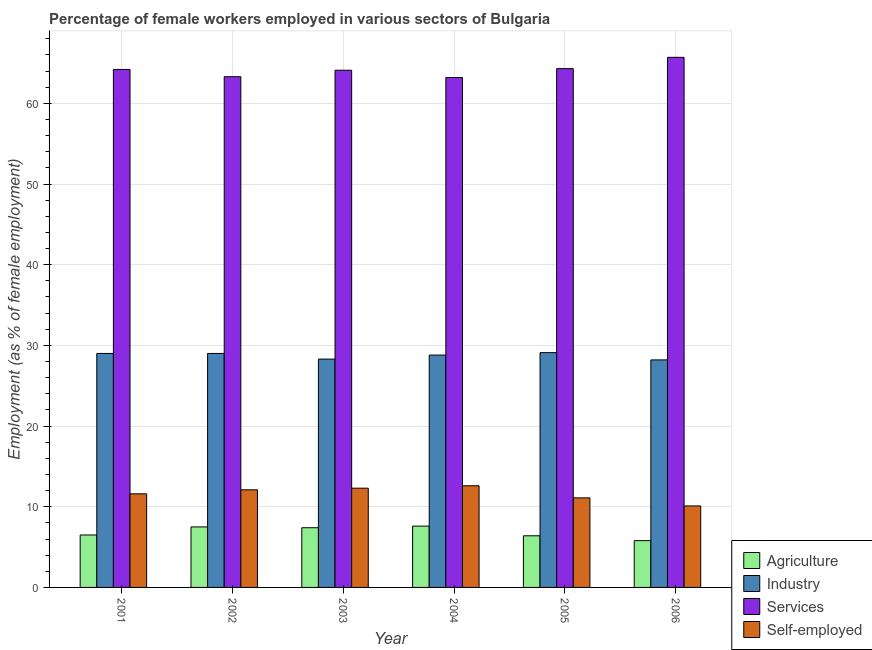How many different coloured bars are there?
Keep it short and to the point. 4. How many groups of bars are there?
Provide a succinct answer. 6. Are the number of bars per tick equal to the number of legend labels?
Your answer should be very brief. Yes. Are the number of bars on each tick of the X-axis equal?
Offer a very short reply. Yes. How many bars are there on the 5th tick from the left?
Provide a succinct answer. 4. In how many cases, is the number of bars for a given year not equal to the number of legend labels?
Your response must be concise. 0. What is the percentage of female workers in services in 2003?
Make the answer very short. 64.1. Across all years, what is the maximum percentage of female workers in agriculture?
Ensure brevity in your answer.  7.6. Across all years, what is the minimum percentage of female workers in services?
Make the answer very short. 63.2. In which year was the percentage of female workers in services maximum?
Your response must be concise. 2006. In which year was the percentage of female workers in services minimum?
Your answer should be very brief. 2004. What is the total percentage of female workers in agriculture in the graph?
Provide a short and direct response. 41.2. What is the difference between the percentage of female workers in agriculture in 2001 and that in 2003?
Provide a succinct answer. -0.9. What is the difference between the percentage of female workers in industry in 2005 and the percentage of female workers in agriculture in 2006?
Ensure brevity in your answer.  0.9. What is the average percentage of female workers in services per year?
Make the answer very short. 64.13. In how many years, is the percentage of female workers in industry greater than 54 %?
Provide a succinct answer. 0. What is the ratio of the percentage of female workers in services in 2002 to that in 2006?
Ensure brevity in your answer.  0.96. What is the difference between the highest and the second highest percentage of female workers in agriculture?
Provide a succinct answer. 0.1. What is the difference between the highest and the lowest percentage of female workers in industry?
Your response must be concise. 0.9. Is the sum of the percentage of female workers in agriculture in 2001 and 2003 greater than the maximum percentage of female workers in industry across all years?
Ensure brevity in your answer.  Yes. Is it the case that in every year, the sum of the percentage of female workers in agriculture and percentage of self employed female workers is greater than the sum of percentage of female workers in services and percentage of female workers in industry?
Provide a succinct answer. No. What does the 3rd bar from the left in 2005 represents?
Give a very brief answer. Services. What does the 3rd bar from the right in 2001 represents?
Provide a short and direct response. Industry. How many bars are there?
Your response must be concise. 24. Are the values on the major ticks of Y-axis written in scientific E-notation?
Provide a succinct answer. No. Does the graph contain any zero values?
Offer a very short reply. No. Does the graph contain grids?
Ensure brevity in your answer.  Yes. Where does the legend appear in the graph?
Provide a short and direct response. Bottom right. How many legend labels are there?
Offer a terse response. 4. What is the title of the graph?
Ensure brevity in your answer.  Percentage of female workers employed in various sectors of Bulgaria. What is the label or title of the Y-axis?
Make the answer very short. Employment (as % of female employment). What is the Employment (as % of female employment) of Agriculture in 2001?
Offer a very short reply. 6.5. What is the Employment (as % of female employment) in Industry in 2001?
Offer a very short reply. 29. What is the Employment (as % of female employment) of Services in 2001?
Give a very brief answer. 64.2. What is the Employment (as % of female employment) in Self-employed in 2001?
Your response must be concise. 11.6. What is the Employment (as % of female employment) of Services in 2002?
Ensure brevity in your answer.  63.3. What is the Employment (as % of female employment) in Self-employed in 2002?
Give a very brief answer. 12.1. What is the Employment (as % of female employment) of Agriculture in 2003?
Give a very brief answer. 7.4. What is the Employment (as % of female employment) of Industry in 2003?
Make the answer very short. 28.3. What is the Employment (as % of female employment) of Services in 2003?
Make the answer very short. 64.1. What is the Employment (as % of female employment) in Self-employed in 2003?
Your answer should be very brief. 12.3. What is the Employment (as % of female employment) of Agriculture in 2004?
Offer a very short reply. 7.6. What is the Employment (as % of female employment) in Industry in 2004?
Your answer should be very brief. 28.8. What is the Employment (as % of female employment) in Services in 2004?
Provide a succinct answer. 63.2. What is the Employment (as % of female employment) of Self-employed in 2004?
Give a very brief answer. 12.6. What is the Employment (as % of female employment) in Agriculture in 2005?
Provide a succinct answer. 6.4. What is the Employment (as % of female employment) in Industry in 2005?
Offer a very short reply. 29.1. What is the Employment (as % of female employment) in Services in 2005?
Offer a very short reply. 64.3. What is the Employment (as % of female employment) in Self-employed in 2005?
Offer a very short reply. 11.1. What is the Employment (as % of female employment) of Agriculture in 2006?
Ensure brevity in your answer.  5.8. What is the Employment (as % of female employment) in Industry in 2006?
Ensure brevity in your answer.  28.2. What is the Employment (as % of female employment) of Services in 2006?
Ensure brevity in your answer.  65.7. What is the Employment (as % of female employment) of Self-employed in 2006?
Offer a very short reply. 10.1. Across all years, what is the maximum Employment (as % of female employment) of Agriculture?
Make the answer very short. 7.6. Across all years, what is the maximum Employment (as % of female employment) in Industry?
Provide a short and direct response. 29.1. Across all years, what is the maximum Employment (as % of female employment) of Services?
Your answer should be very brief. 65.7. Across all years, what is the maximum Employment (as % of female employment) in Self-employed?
Provide a short and direct response. 12.6. Across all years, what is the minimum Employment (as % of female employment) in Agriculture?
Your response must be concise. 5.8. Across all years, what is the minimum Employment (as % of female employment) in Industry?
Your answer should be compact. 28.2. Across all years, what is the minimum Employment (as % of female employment) of Services?
Offer a terse response. 63.2. Across all years, what is the minimum Employment (as % of female employment) in Self-employed?
Your answer should be compact. 10.1. What is the total Employment (as % of female employment) in Agriculture in the graph?
Keep it short and to the point. 41.2. What is the total Employment (as % of female employment) of Industry in the graph?
Your answer should be very brief. 172.4. What is the total Employment (as % of female employment) of Services in the graph?
Offer a very short reply. 384.8. What is the total Employment (as % of female employment) of Self-employed in the graph?
Offer a terse response. 69.8. What is the difference between the Employment (as % of female employment) of Industry in 2001 and that in 2002?
Offer a very short reply. 0. What is the difference between the Employment (as % of female employment) in Agriculture in 2001 and that in 2003?
Offer a very short reply. -0.9. What is the difference between the Employment (as % of female employment) in Industry in 2001 and that in 2003?
Keep it short and to the point. 0.7. What is the difference between the Employment (as % of female employment) of Agriculture in 2001 and that in 2004?
Your answer should be very brief. -1.1. What is the difference between the Employment (as % of female employment) in Services in 2001 and that in 2005?
Give a very brief answer. -0.1. What is the difference between the Employment (as % of female employment) in Self-employed in 2001 and that in 2005?
Ensure brevity in your answer.  0.5. What is the difference between the Employment (as % of female employment) of Industry in 2001 and that in 2006?
Offer a terse response. 0.8. What is the difference between the Employment (as % of female employment) in Services in 2001 and that in 2006?
Provide a succinct answer. -1.5. What is the difference between the Employment (as % of female employment) in Self-employed in 2001 and that in 2006?
Ensure brevity in your answer.  1.5. What is the difference between the Employment (as % of female employment) of Services in 2002 and that in 2003?
Offer a terse response. -0.8. What is the difference between the Employment (as % of female employment) of Self-employed in 2002 and that in 2003?
Provide a short and direct response. -0.2. What is the difference between the Employment (as % of female employment) in Agriculture in 2002 and that in 2004?
Make the answer very short. -0.1. What is the difference between the Employment (as % of female employment) in Self-employed in 2002 and that in 2004?
Give a very brief answer. -0.5. What is the difference between the Employment (as % of female employment) of Agriculture in 2002 and that in 2005?
Your response must be concise. 1.1. What is the difference between the Employment (as % of female employment) of Services in 2002 and that in 2005?
Offer a very short reply. -1. What is the difference between the Employment (as % of female employment) in Self-employed in 2002 and that in 2005?
Your answer should be very brief. 1. What is the difference between the Employment (as % of female employment) of Industry in 2002 and that in 2006?
Your response must be concise. 0.8. What is the difference between the Employment (as % of female employment) in Services in 2002 and that in 2006?
Your answer should be very brief. -2.4. What is the difference between the Employment (as % of female employment) in Self-employed in 2002 and that in 2006?
Provide a short and direct response. 2. What is the difference between the Employment (as % of female employment) of Agriculture in 2003 and that in 2004?
Ensure brevity in your answer.  -0.2. What is the difference between the Employment (as % of female employment) of Industry in 2003 and that in 2004?
Ensure brevity in your answer.  -0.5. What is the difference between the Employment (as % of female employment) of Services in 2003 and that in 2005?
Keep it short and to the point. -0.2. What is the difference between the Employment (as % of female employment) of Self-employed in 2003 and that in 2005?
Keep it short and to the point. 1.2. What is the difference between the Employment (as % of female employment) in Services in 2003 and that in 2006?
Give a very brief answer. -1.6. What is the difference between the Employment (as % of female employment) in Self-employed in 2003 and that in 2006?
Keep it short and to the point. 2.2. What is the difference between the Employment (as % of female employment) in Self-employed in 2004 and that in 2005?
Make the answer very short. 1.5. What is the difference between the Employment (as % of female employment) in Services in 2005 and that in 2006?
Your response must be concise. -1.4. What is the difference between the Employment (as % of female employment) of Self-employed in 2005 and that in 2006?
Your answer should be compact. 1. What is the difference between the Employment (as % of female employment) in Agriculture in 2001 and the Employment (as % of female employment) in Industry in 2002?
Provide a short and direct response. -22.5. What is the difference between the Employment (as % of female employment) of Agriculture in 2001 and the Employment (as % of female employment) of Services in 2002?
Offer a terse response. -56.8. What is the difference between the Employment (as % of female employment) of Industry in 2001 and the Employment (as % of female employment) of Services in 2002?
Give a very brief answer. -34.3. What is the difference between the Employment (as % of female employment) of Industry in 2001 and the Employment (as % of female employment) of Self-employed in 2002?
Your response must be concise. 16.9. What is the difference between the Employment (as % of female employment) in Services in 2001 and the Employment (as % of female employment) in Self-employed in 2002?
Provide a short and direct response. 52.1. What is the difference between the Employment (as % of female employment) in Agriculture in 2001 and the Employment (as % of female employment) in Industry in 2003?
Ensure brevity in your answer.  -21.8. What is the difference between the Employment (as % of female employment) in Agriculture in 2001 and the Employment (as % of female employment) in Services in 2003?
Offer a terse response. -57.6. What is the difference between the Employment (as % of female employment) of Industry in 2001 and the Employment (as % of female employment) of Services in 2003?
Your response must be concise. -35.1. What is the difference between the Employment (as % of female employment) in Industry in 2001 and the Employment (as % of female employment) in Self-employed in 2003?
Give a very brief answer. 16.7. What is the difference between the Employment (as % of female employment) of Services in 2001 and the Employment (as % of female employment) of Self-employed in 2003?
Give a very brief answer. 51.9. What is the difference between the Employment (as % of female employment) in Agriculture in 2001 and the Employment (as % of female employment) in Industry in 2004?
Give a very brief answer. -22.3. What is the difference between the Employment (as % of female employment) in Agriculture in 2001 and the Employment (as % of female employment) in Services in 2004?
Offer a very short reply. -56.7. What is the difference between the Employment (as % of female employment) of Industry in 2001 and the Employment (as % of female employment) of Services in 2004?
Provide a short and direct response. -34.2. What is the difference between the Employment (as % of female employment) of Services in 2001 and the Employment (as % of female employment) of Self-employed in 2004?
Make the answer very short. 51.6. What is the difference between the Employment (as % of female employment) of Agriculture in 2001 and the Employment (as % of female employment) of Industry in 2005?
Keep it short and to the point. -22.6. What is the difference between the Employment (as % of female employment) in Agriculture in 2001 and the Employment (as % of female employment) in Services in 2005?
Your answer should be compact. -57.8. What is the difference between the Employment (as % of female employment) in Agriculture in 2001 and the Employment (as % of female employment) in Self-employed in 2005?
Provide a succinct answer. -4.6. What is the difference between the Employment (as % of female employment) in Industry in 2001 and the Employment (as % of female employment) in Services in 2005?
Make the answer very short. -35.3. What is the difference between the Employment (as % of female employment) of Industry in 2001 and the Employment (as % of female employment) of Self-employed in 2005?
Provide a short and direct response. 17.9. What is the difference between the Employment (as % of female employment) in Services in 2001 and the Employment (as % of female employment) in Self-employed in 2005?
Your answer should be compact. 53.1. What is the difference between the Employment (as % of female employment) in Agriculture in 2001 and the Employment (as % of female employment) in Industry in 2006?
Your answer should be very brief. -21.7. What is the difference between the Employment (as % of female employment) in Agriculture in 2001 and the Employment (as % of female employment) in Services in 2006?
Ensure brevity in your answer.  -59.2. What is the difference between the Employment (as % of female employment) of Industry in 2001 and the Employment (as % of female employment) of Services in 2006?
Your response must be concise. -36.7. What is the difference between the Employment (as % of female employment) of Services in 2001 and the Employment (as % of female employment) of Self-employed in 2006?
Provide a short and direct response. 54.1. What is the difference between the Employment (as % of female employment) of Agriculture in 2002 and the Employment (as % of female employment) of Industry in 2003?
Make the answer very short. -20.8. What is the difference between the Employment (as % of female employment) of Agriculture in 2002 and the Employment (as % of female employment) of Services in 2003?
Keep it short and to the point. -56.6. What is the difference between the Employment (as % of female employment) in Industry in 2002 and the Employment (as % of female employment) in Services in 2003?
Offer a terse response. -35.1. What is the difference between the Employment (as % of female employment) of Industry in 2002 and the Employment (as % of female employment) of Self-employed in 2003?
Offer a very short reply. 16.7. What is the difference between the Employment (as % of female employment) of Agriculture in 2002 and the Employment (as % of female employment) of Industry in 2004?
Keep it short and to the point. -21.3. What is the difference between the Employment (as % of female employment) in Agriculture in 2002 and the Employment (as % of female employment) in Services in 2004?
Make the answer very short. -55.7. What is the difference between the Employment (as % of female employment) in Industry in 2002 and the Employment (as % of female employment) in Services in 2004?
Offer a very short reply. -34.2. What is the difference between the Employment (as % of female employment) in Services in 2002 and the Employment (as % of female employment) in Self-employed in 2004?
Provide a succinct answer. 50.7. What is the difference between the Employment (as % of female employment) in Agriculture in 2002 and the Employment (as % of female employment) in Industry in 2005?
Offer a terse response. -21.6. What is the difference between the Employment (as % of female employment) of Agriculture in 2002 and the Employment (as % of female employment) of Services in 2005?
Make the answer very short. -56.8. What is the difference between the Employment (as % of female employment) in Agriculture in 2002 and the Employment (as % of female employment) in Self-employed in 2005?
Your answer should be very brief. -3.6. What is the difference between the Employment (as % of female employment) in Industry in 2002 and the Employment (as % of female employment) in Services in 2005?
Offer a very short reply. -35.3. What is the difference between the Employment (as % of female employment) in Industry in 2002 and the Employment (as % of female employment) in Self-employed in 2005?
Offer a terse response. 17.9. What is the difference between the Employment (as % of female employment) in Services in 2002 and the Employment (as % of female employment) in Self-employed in 2005?
Offer a terse response. 52.2. What is the difference between the Employment (as % of female employment) in Agriculture in 2002 and the Employment (as % of female employment) in Industry in 2006?
Ensure brevity in your answer.  -20.7. What is the difference between the Employment (as % of female employment) of Agriculture in 2002 and the Employment (as % of female employment) of Services in 2006?
Offer a terse response. -58.2. What is the difference between the Employment (as % of female employment) in Industry in 2002 and the Employment (as % of female employment) in Services in 2006?
Your answer should be compact. -36.7. What is the difference between the Employment (as % of female employment) in Industry in 2002 and the Employment (as % of female employment) in Self-employed in 2006?
Your answer should be very brief. 18.9. What is the difference between the Employment (as % of female employment) of Services in 2002 and the Employment (as % of female employment) of Self-employed in 2006?
Ensure brevity in your answer.  53.2. What is the difference between the Employment (as % of female employment) of Agriculture in 2003 and the Employment (as % of female employment) of Industry in 2004?
Give a very brief answer. -21.4. What is the difference between the Employment (as % of female employment) in Agriculture in 2003 and the Employment (as % of female employment) in Services in 2004?
Keep it short and to the point. -55.8. What is the difference between the Employment (as % of female employment) in Industry in 2003 and the Employment (as % of female employment) in Services in 2004?
Ensure brevity in your answer.  -34.9. What is the difference between the Employment (as % of female employment) in Industry in 2003 and the Employment (as % of female employment) in Self-employed in 2004?
Your answer should be compact. 15.7. What is the difference between the Employment (as % of female employment) of Services in 2003 and the Employment (as % of female employment) of Self-employed in 2004?
Give a very brief answer. 51.5. What is the difference between the Employment (as % of female employment) in Agriculture in 2003 and the Employment (as % of female employment) in Industry in 2005?
Give a very brief answer. -21.7. What is the difference between the Employment (as % of female employment) of Agriculture in 2003 and the Employment (as % of female employment) of Services in 2005?
Keep it short and to the point. -56.9. What is the difference between the Employment (as % of female employment) of Agriculture in 2003 and the Employment (as % of female employment) of Self-employed in 2005?
Give a very brief answer. -3.7. What is the difference between the Employment (as % of female employment) of Industry in 2003 and the Employment (as % of female employment) of Services in 2005?
Give a very brief answer. -36. What is the difference between the Employment (as % of female employment) of Industry in 2003 and the Employment (as % of female employment) of Self-employed in 2005?
Provide a succinct answer. 17.2. What is the difference between the Employment (as % of female employment) in Services in 2003 and the Employment (as % of female employment) in Self-employed in 2005?
Make the answer very short. 53. What is the difference between the Employment (as % of female employment) in Agriculture in 2003 and the Employment (as % of female employment) in Industry in 2006?
Your response must be concise. -20.8. What is the difference between the Employment (as % of female employment) of Agriculture in 2003 and the Employment (as % of female employment) of Services in 2006?
Offer a terse response. -58.3. What is the difference between the Employment (as % of female employment) in Agriculture in 2003 and the Employment (as % of female employment) in Self-employed in 2006?
Your response must be concise. -2.7. What is the difference between the Employment (as % of female employment) of Industry in 2003 and the Employment (as % of female employment) of Services in 2006?
Give a very brief answer. -37.4. What is the difference between the Employment (as % of female employment) in Industry in 2003 and the Employment (as % of female employment) in Self-employed in 2006?
Ensure brevity in your answer.  18.2. What is the difference between the Employment (as % of female employment) of Services in 2003 and the Employment (as % of female employment) of Self-employed in 2006?
Ensure brevity in your answer.  54. What is the difference between the Employment (as % of female employment) of Agriculture in 2004 and the Employment (as % of female employment) of Industry in 2005?
Ensure brevity in your answer.  -21.5. What is the difference between the Employment (as % of female employment) in Agriculture in 2004 and the Employment (as % of female employment) in Services in 2005?
Offer a terse response. -56.7. What is the difference between the Employment (as % of female employment) of Agriculture in 2004 and the Employment (as % of female employment) of Self-employed in 2005?
Keep it short and to the point. -3.5. What is the difference between the Employment (as % of female employment) of Industry in 2004 and the Employment (as % of female employment) of Services in 2005?
Offer a very short reply. -35.5. What is the difference between the Employment (as % of female employment) in Industry in 2004 and the Employment (as % of female employment) in Self-employed in 2005?
Provide a succinct answer. 17.7. What is the difference between the Employment (as % of female employment) in Services in 2004 and the Employment (as % of female employment) in Self-employed in 2005?
Your response must be concise. 52.1. What is the difference between the Employment (as % of female employment) of Agriculture in 2004 and the Employment (as % of female employment) of Industry in 2006?
Keep it short and to the point. -20.6. What is the difference between the Employment (as % of female employment) of Agriculture in 2004 and the Employment (as % of female employment) of Services in 2006?
Provide a short and direct response. -58.1. What is the difference between the Employment (as % of female employment) of Industry in 2004 and the Employment (as % of female employment) of Services in 2006?
Your answer should be very brief. -36.9. What is the difference between the Employment (as % of female employment) of Industry in 2004 and the Employment (as % of female employment) of Self-employed in 2006?
Offer a very short reply. 18.7. What is the difference between the Employment (as % of female employment) in Services in 2004 and the Employment (as % of female employment) in Self-employed in 2006?
Your answer should be very brief. 53.1. What is the difference between the Employment (as % of female employment) of Agriculture in 2005 and the Employment (as % of female employment) of Industry in 2006?
Provide a succinct answer. -21.8. What is the difference between the Employment (as % of female employment) in Agriculture in 2005 and the Employment (as % of female employment) in Services in 2006?
Provide a succinct answer. -59.3. What is the difference between the Employment (as % of female employment) of Agriculture in 2005 and the Employment (as % of female employment) of Self-employed in 2006?
Your answer should be compact. -3.7. What is the difference between the Employment (as % of female employment) of Industry in 2005 and the Employment (as % of female employment) of Services in 2006?
Make the answer very short. -36.6. What is the difference between the Employment (as % of female employment) in Services in 2005 and the Employment (as % of female employment) in Self-employed in 2006?
Your response must be concise. 54.2. What is the average Employment (as % of female employment) in Agriculture per year?
Keep it short and to the point. 6.87. What is the average Employment (as % of female employment) in Industry per year?
Ensure brevity in your answer.  28.73. What is the average Employment (as % of female employment) of Services per year?
Offer a very short reply. 64.13. What is the average Employment (as % of female employment) in Self-employed per year?
Provide a short and direct response. 11.63. In the year 2001, what is the difference between the Employment (as % of female employment) of Agriculture and Employment (as % of female employment) of Industry?
Provide a short and direct response. -22.5. In the year 2001, what is the difference between the Employment (as % of female employment) in Agriculture and Employment (as % of female employment) in Services?
Provide a succinct answer. -57.7. In the year 2001, what is the difference between the Employment (as % of female employment) in Agriculture and Employment (as % of female employment) in Self-employed?
Make the answer very short. -5.1. In the year 2001, what is the difference between the Employment (as % of female employment) in Industry and Employment (as % of female employment) in Services?
Your answer should be very brief. -35.2. In the year 2001, what is the difference between the Employment (as % of female employment) of Services and Employment (as % of female employment) of Self-employed?
Provide a succinct answer. 52.6. In the year 2002, what is the difference between the Employment (as % of female employment) of Agriculture and Employment (as % of female employment) of Industry?
Offer a very short reply. -21.5. In the year 2002, what is the difference between the Employment (as % of female employment) of Agriculture and Employment (as % of female employment) of Services?
Your response must be concise. -55.8. In the year 2002, what is the difference between the Employment (as % of female employment) in Industry and Employment (as % of female employment) in Services?
Give a very brief answer. -34.3. In the year 2002, what is the difference between the Employment (as % of female employment) of Services and Employment (as % of female employment) of Self-employed?
Ensure brevity in your answer.  51.2. In the year 2003, what is the difference between the Employment (as % of female employment) of Agriculture and Employment (as % of female employment) of Industry?
Offer a terse response. -20.9. In the year 2003, what is the difference between the Employment (as % of female employment) in Agriculture and Employment (as % of female employment) in Services?
Provide a succinct answer. -56.7. In the year 2003, what is the difference between the Employment (as % of female employment) in Industry and Employment (as % of female employment) in Services?
Offer a terse response. -35.8. In the year 2003, what is the difference between the Employment (as % of female employment) of Services and Employment (as % of female employment) of Self-employed?
Give a very brief answer. 51.8. In the year 2004, what is the difference between the Employment (as % of female employment) of Agriculture and Employment (as % of female employment) of Industry?
Offer a very short reply. -21.2. In the year 2004, what is the difference between the Employment (as % of female employment) of Agriculture and Employment (as % of female employment) of Services?
Your answer should be compact. -55.6. In the year 2004, what is the difference between the Employment (as % of female employment) of Industry and Employment (as % of female employment) of Services?
Offer a terse response. -34.4. In the year 2004, what is the difference between the Employment (as % of female employment) of Services and Employment (as % of female employment) of Self-employed?
Give a very brief answer. 50.6. In the year 2005, what is the difference between the Employment (as % of female employment) of Agriculture and Employment (as % of female employment) of Industry?
Provide a succinct answer. -22.7. In the year 2005, what is the difference between the Employment (as % of female employment) of Agriculture and Employment (as % of female employment) of Services?
Ensure brevity in your answer.  -57.9. In the year 2005, what is the difference between the Employment (as % of female employment) of Industry and Employment (as % of female employment) of Services?
Your answer should be very brief. -35.2. In the year 2005, what is the difference between the Employment (as % of female employment) in Industry and Employment (as % of female employment) in Self-employed?
Provide a succinct answer. 18. In the year 2005, what is the difference between the Employment (as % of female employment) of Services and Employment (as % of female employment) of Self-employed?
Offer a terse response. 53.2. In the year 2006, what is the difference between the Employment (as % of female employment) of Agriculture and Employment (as % of female employment) of Industry?
Give a very brief answer. -22.4. In the year 2006, what is the difference between the Employment (as % of female employment) in Agriculture and Employment (as % of female employment) in Services?
Make the answer very short. -59.9. In the year 2006, what is the difference between the Employment (as % of female employment) in Agriculture and Employment (as % of female employment) in Self-employed?
Your answer should be very brief. -4.3. In the year 2006, what is the difference between the Employment (as % of female employment) of Industry and Employment (as % of female employment) of Services?
Give a very brief answer. -37.5. In the year 2006, what is the difference between the Employment (as % of female employment) in Industry and Employment (as % of female employment) in Self-employed?
Provide a succinct answer. 18.1. In the year 2006, what is the difference between the Employment (as % of female employment) in Services and Employment (as % of female employment) in Self-employed?
Offer a very short reply. 55.6. What is the ratio of the Employment (as % of female employment) of Agriculture in 2001 to that in 2002?
Provide a succinct answer. 0.87. What is the ratio of the Employment (as % of female employment) of Services in 2001 to that in 2002?
Ensure brevity in your answer.  1.01. What is the ratio of the Employment (as % of female employment) of Self-employed in 2001 to that in 2002?
Give a very brief answer. 0.96. What is the ratio of the Employment (as % of female employment) in Agriculture in 2001 to that in 2003?
Offer a terse response. 0.88. What is the ratio of the Employment (as % of female employment) in Industry in 2001 to that in 2003?
Your answer should be compact. 1.02. What is the ratio of the Employment (as % of female employment) of Self-employed in 2001 to that in 2003?
Offer a terse response. 0.94. What is the ratio of the Employment (as % of female employment) of Agriculture in 2001 to that in 2004?
Your response must be concise. 0.86. What is the ratio of the Employment (as % of female employment) of Services in 2001 to that in 2004?
Offer a terse response. 1.02. What is the ratio of the Employment (as % of female employment) of Self-employed in 2001 to that in 2004?
Your response must be concise. 0.92. What is the ratio of the Employment (as % of female employment) in Agriculture in 2001 to that in 2005?
Provide a succinct answer. 1.02. What is the ratio of the Employment (as % of female employment) of Services in 2001 to that in 2005?
Provide a succinct answer. 1. What is the ratio of the Employment (as % of female employment) of Self-employed in 2001 to that in 2005?
Give a very brief answer. 1.04. What is the ratio of the Employment (as % of female employment) of Agriculture in 2001 to that in 2006?
Provide a short and direct response. 1.12. What is the ratio of the Employment (as % of female employment) in Industry in 2001 to that in 2006?
Your answer should be compact. 1.03. What is the ratio of the Employment (as % of female employment) in Services in 2001 to that in 2006?
Ensure brevity in your answer.  0.98. What is the ratio of the Employment (as % of female employment) of Self-employed in 2001 to that in 2006?
Ensure brevity in your answer.  1.15. What is the ratio of the Employment (as % of female employment) of Agriculture in 2002 to that in 2003?
Your response must be concise. 1.01. What is the ratio of the Employment (as % of female employment) in Industry in 2002 to that in 2003?
Ensure brevity in your answer.  1.02. What is the ratio of the Employment (as % of female employment) in Services in 2002 to that in 2003?
Provide a short and direct response. 0.99. What is the ratio of the Employment (as % of female employment) in Self-employed in 2002 to that in 2003?
Offer a very short reply. 0.98. What is the ratio of the Employment (as % of female employment) of Services in 2002 to that in 2004?
Provide a short and direct response. 1. What is the ratio of the Employment (as % of female employment) of Self-employed in 2002 to that in 2004?
Ensure brevity in your answer.  0.96. What is the ratio of the Employment (as % of female employment) of Agriculture in 2002 to that in 2005?
Your answer should be compact. 1.17. What is the ratio of the Employment (as % of female employment) in Industry in 2002 to that in 2005?
Give a very brief answer. 1. What is the ratio of the Employment (as % of female employment) of Services in 2002 to that in 2005?
Make the answer very short. 0.98. What is the ratio of the Employment (as % of female employment) of Self-employed in 2002 to that in 2005?
Your answer should be compact. 1.09. What is the ratio of the Employment (as % of female employment) of Agriculture in 2002 to that in 2006?
Provide a succinct answer. 1.29. What is the ratio of the Employment (as % of female employment) in Industry in 2002 to that in 2006?
Your answer should be very brief. 1.03. What is the ratio of the Employment (as % of female employment) of Services in 2002 to that in 2006?
Ensure brevity in your answer.  0.96. What is the ratio of the Employment (as % of female employment) in Self-employed in 2002 to that in 2006?
Provide a succinct answer. 1.2. What is the ratio of the Employment (as % of female employment) in Agriculture in 2003 to that in 2004?
Offer a very short reply. 0.97. What is the ratio of the Employment (as % of female employment) in Industry in 2003 to that in 2004?
Offer a very short reply. 0.98. What is the ratio of the Employment (as % of female employment) in Services in 2003 to that in 2004?
Make the answer very short. 1.01. What is the ratio of the Employment (as % of female employment) in Self-employed in 2003 to that in 2004?
Provide a succinct answer. 0.98. What is the ratio of the Employment (as % of female employment) in Agriculture in 2003 to that in 2005?
Your answer should be very brief. 1.16. What is the ratio of the Employment (as % of female employment) in Industry in 2003 to that in 2005?
Provide a succinct answer. 0.97. What is the ratio of the Employment (as % of female employment) of Services in 2003 to that in 2005?
Offer a very short reply. 1. What is the ratio of the Employment (as % of female employment) in Self-employed in 2003 to that in 2005?
Your answer should be compact. 1.11. What is the ratio of the Employment (as % of female employment) in Agriculture in 2003 to that in 2006?
Provide a succinct answer. 1.28. What is the ratio of the Employment (as % of female employment) of Services in 2003 to that in 2006?
Offer a terse response. 0.98. What is the ratio of the Employment (as % of female employment) of Self-employed in 2003 to that in 2006?
Provide a short and direct response. 1.22. What is the ratio of the Employment (as % of female employment) in Agriculture in 2004 to that in 2005?
Provide a succinct answer. 1.19. What is the ratio of the Employment (as % of female employment) in Industry in 2004 to that in 2005?
Ensure brevity in your answer.  0.99. What is the ratio of the Employment (as % of female employment) in Services in 2004 to that in 2005?
Give a very brief answer. 0.98. What is the ratio of the Employment (as % of female employment) in Self-employed in 2004 to that in 2005?
Offer a terse response. 1.14. What is the ratio of the Employment (as % of female employment) of Agriculture in 2004 to that in 2006?
Your answer should be compact. 1.31. What is the ratio of the Employment (as % of female employment) of Industry in 2004 to that in 2006?
Keep it short and to the point. 1.02. What is the ratio of the Employment (as % of female employment) of Services in 2004 to that in 2006?
Offer a terse response. 0.96. What is the ratio of the Employment (as % of female employment) of Self-employed in 2004 to that in 2006?
Provide a short and direct response. 1.25. What is the ratio of the Employment (as % of female employment) in Agriculture in 2005 to that in 2006?
Offer a terse response. 1.1. What is the ratio of the Employment (as % of female employment) in Industry in 2005 to that in 2006?
Offer a terse response. 1.03. What is the ratio of the Employment (as % of female employment) of Services in 2005 to that in 2006?
Offer a terse response. 0.98. What is the ratio of the Employment (as % of female employment) in Self-employed in 2005 to that in 2006?
Provide a succinct answer. 1.1. What is the difference between the highest and the second highest Employment (as % of female employment) of Self-employed?
Provide a succinct answer. 0.3. What is the difference between the highest and the lowest Employment (as % of female employment) in Agriculture?
Make the answer very short. 1.8. What is the difference between the highest and the lowest Employment (as % of female employment) in Industry?
Ensure brevity in your answer.  0.9. What is the difference between the highest and the lowest Employment (as % of female employment) in Services?
Offer a terse response. 2.5. 